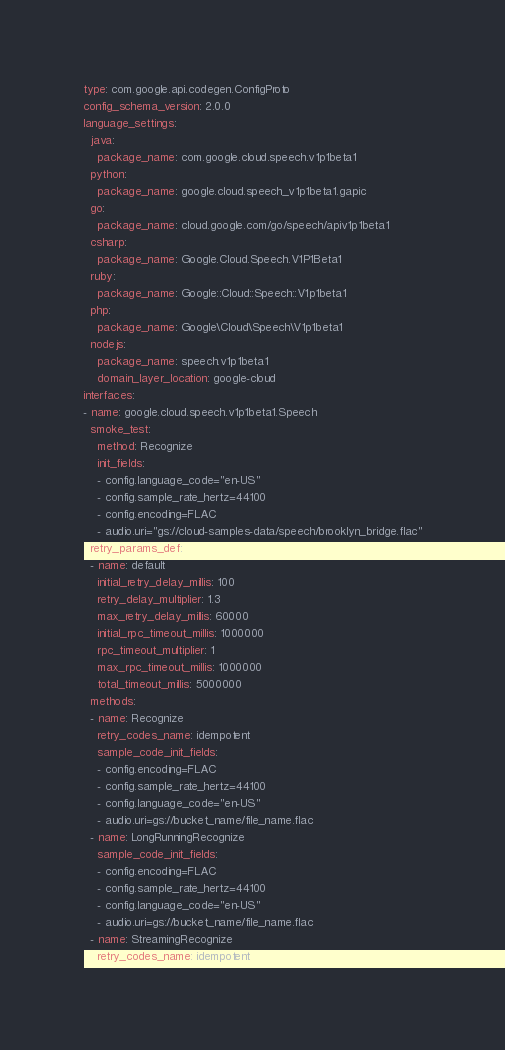Convert code to text. <code><loc_0><loc_0><loc_500><loc_500><_YAML_>type: com.google.api.codegen.ConfigProto
config_schema_version: 2.0.0
language_settings:
  java:
    package_name: com.google.cloud.speech.v1p1beta1
  python:
    package_name: google.cloud.speech_v1p1beta1.gapic
  go:
    package_name: cloud.google.com/go/speech/apiv1p1beta1
  csharp:
    package_name: Google.Cloud.Speech.V1P1Beta1
  ruby:
    package_name: Google::Cloud::Speech::V1p1beta1
  php:
    package_name: Google\Cloud\Speech\V1p1beta1
  nodejs:
    package_name: speech.v1p1beta1
    domain_layer_location: google-cloud
interfaces:
- name: google.cloud.speech.v1p1beta1.Speech
  smoke_test:
    method: Recognize
    init_fields:
    - config.language_code="en-US"
    - config.sample_rate_hertz=44100
    - config.encoding=FLAC
    - audio.uri="gs://cloud-samples-data/speech/brooklyn_bridge.flac"
  retry_params_def:
  - name: default
    initial_retry_delay_millis: 100
    retry_delay_multiplier: 1.3
    max_retry_delay_millis: 60000
    initial_rpc_timeout_millis: 1000000
    rpc_timeout_multiplier: 1
    max_rpc_timeout_millis: 1000000
    total_timeout_millis: 5000000
  methods:
  - name: Recognize
    retry_codes_name: idempotent
    sample_code_init_fields:
    - config.encoding=FLAC
    - config.sample_rate_hertz=44100
    - config.language_code="en-US"
    - audio.uri=gs://bucket_name/file_name.flac
  - name: LongRunningRecognize
    sample_code_init_fields:
    - config.encoding=FLAC
    - config.sample_rate_hertz=44100
    - config.language_code="en-US"
    - audio.uri=gs://bucket_name/file_name.flac
  - name: StreamingRecognize
    retry_codes_name: idempotent
</code> 